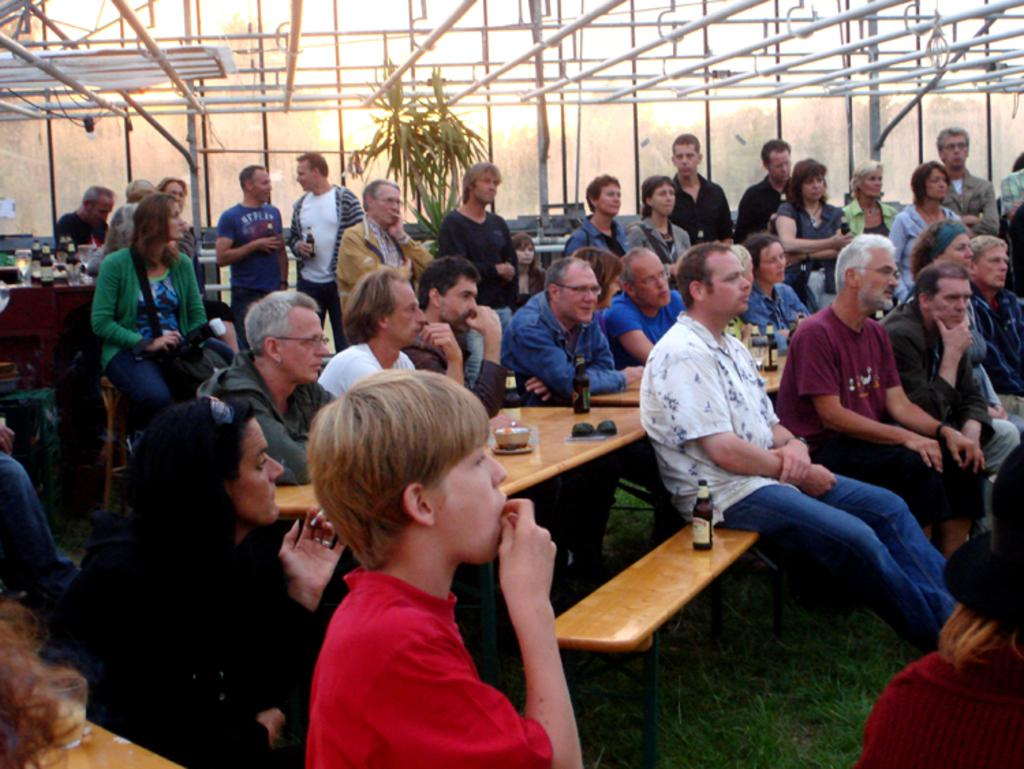What type of vegetation can be seen in the background of the image? There is a plant in the background of the image. What objects are on the table in the image? There are bottles on a table in the image. What are the persons in the image doing? All the persons are sitting on benches in the image. What type of surface is visible in the image? There is grass in the image. How many plantations are visible in the image? There is no plantation present in the image; it only features a single plant in the background. Can you tell me how the persons in the image plan to join the group? The image does not show any indication of the persons joining a group or any related actions. 